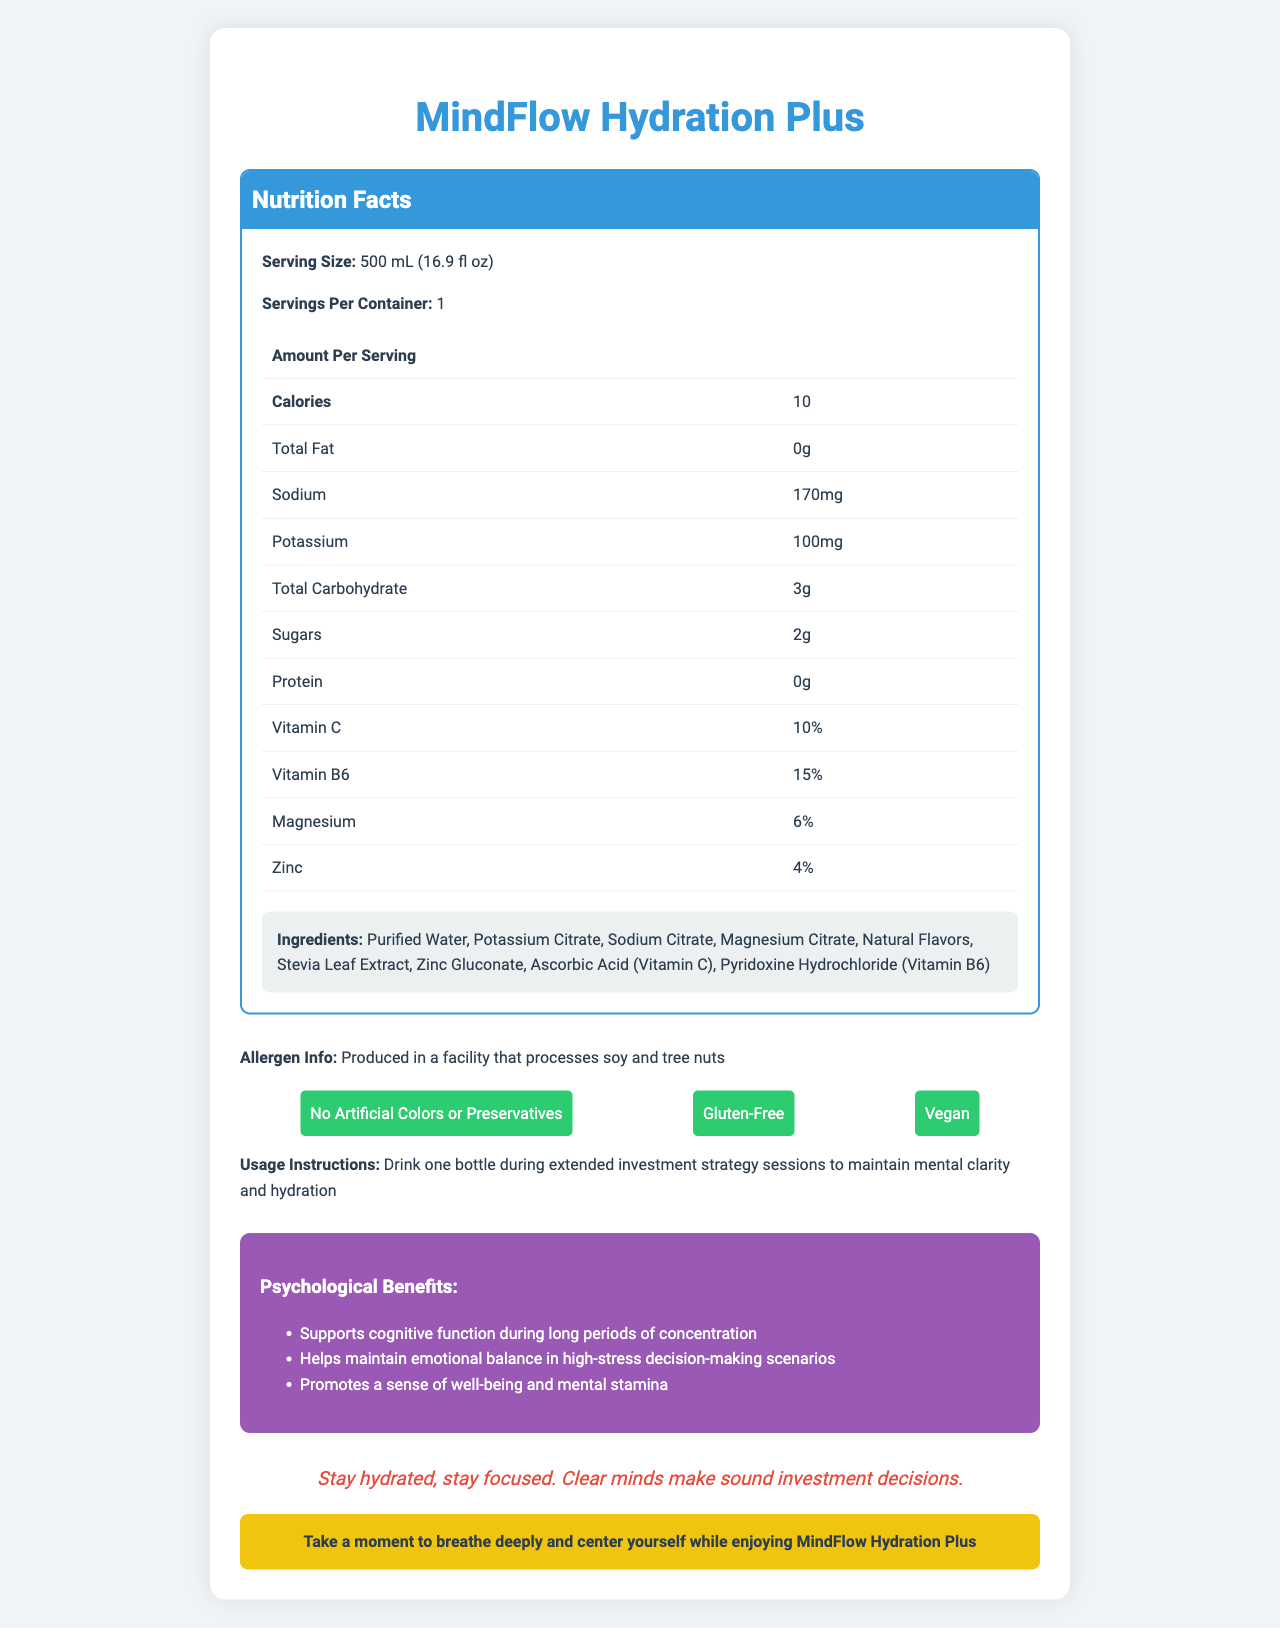what is the serving size? The serving size is stated at the beginning of the Nutrition Facts section of the document.
Answer: 500 mL (16.9 fl oz) how many calories are in MindFlow Hydration Plus? The Nutrition Facts table lists the amount of calories as 10 per serving.
Answer: 10 how much sodium does the product contain? The table under the Nutrition Facts lists the sodium content as 170 mg.
Answer: 170 mg what vitamins are included in MindFlow Hydration Plus? The document lists Vitamin C (10%) and Vitamin B6 (15%) in the Nutrition Facts.
Answer: Vitamin C and Vitamin B6 what are the specific ingredients in MindFlow Hydration Plus? These ingredients are listed in the Ingredients section of the Nutrition Facts.
Answer: Purified Water, Potassium Citrate, Sodium Citrate, Magnesium Citrate, Natural Flavors, Stevia Leaf Extract, Zinc Gluconate, Ascorbic Acid (Vitamin C), Pyridoxine Hydrochloride (Vitamin B6) what is the bottle's volume in fluid ounces? The serving size is listed as 500 mL (16.9 fl oz), providing the fluid ounce measurement.
Answer: 16.9 fl oz does the product contain any fat? The Nutrition Facts table lists the total fat as 0g, indicating that the product does not contain any fat.
Answer: No what is one of the psychological benefits of drinking MindFlow Hydration Plus? The section on psychological benefits lists "Supports cognitive function during long periods of concentration" as one of the benefits.
Answer: Supports cognitive function during long periods of concentration what allergens might be present in MindFlow Hydration Plus? The allergen information states that it is produced in a facility that processes soy and tree nuts.
Answer: Soy and tree nuts what is the main idea of the MindFlow Hydration Plus document? The document details the nutritional content, ingredients, allergen information, special features, usage instructions, psychological benefits, and provides an investment wisdom tip for staying hydrated.
Answer: MindFlow Hydration Plus is an electrolyte-enhanced water designed to maintain hydration and mental clarity during long investment sessions, containing essential electrolytes and vitamins, and offering specific psychological benefits. are there any artificial colors or preservatives in MindFlow Hydration Plus? The special features section specifies "No Artificial Colors or Preservatives".
Answer: No which mineral is present in the smallest amount? A. Sodium B. Potassium C. Magnesium D. Zinc The Nutrition Facts list the mineral amounts as: Sodium 170 mg, Potassium 100 mg, Magnesium 6%, Zinc 4%. Zinc is present in the smallest amount.
Answer: D. Zinc how is MindFlow Hydration Plus recommended to be used? A. During exercise B. During meals C. During extended investment strategy sessions D. First thing in the morning The usage instructions specifically state to drink one bottle during extended investment strategy sessions.
Answer: C. During extended investment strategy sessions does the product recommend drinking it in stressful situations? The psychological benefits mention that it helps maintain emotional balance in high-stress decision-making scenarios.
Answer: Yes what percentage of magnesium does the product provide? The Nutrition Facts states that MindFlow Hydration Plus provides 6% of the daily value for magnesium.
Answer: 6% can the exact nutritional profile of MindFlow Hydration Plus's next flavor variant be found in the document? The document only provides information about the current product, MindFlow Hydration Plus, without details regarding any future or different flavor variants.
Answer: Cannot be determined 